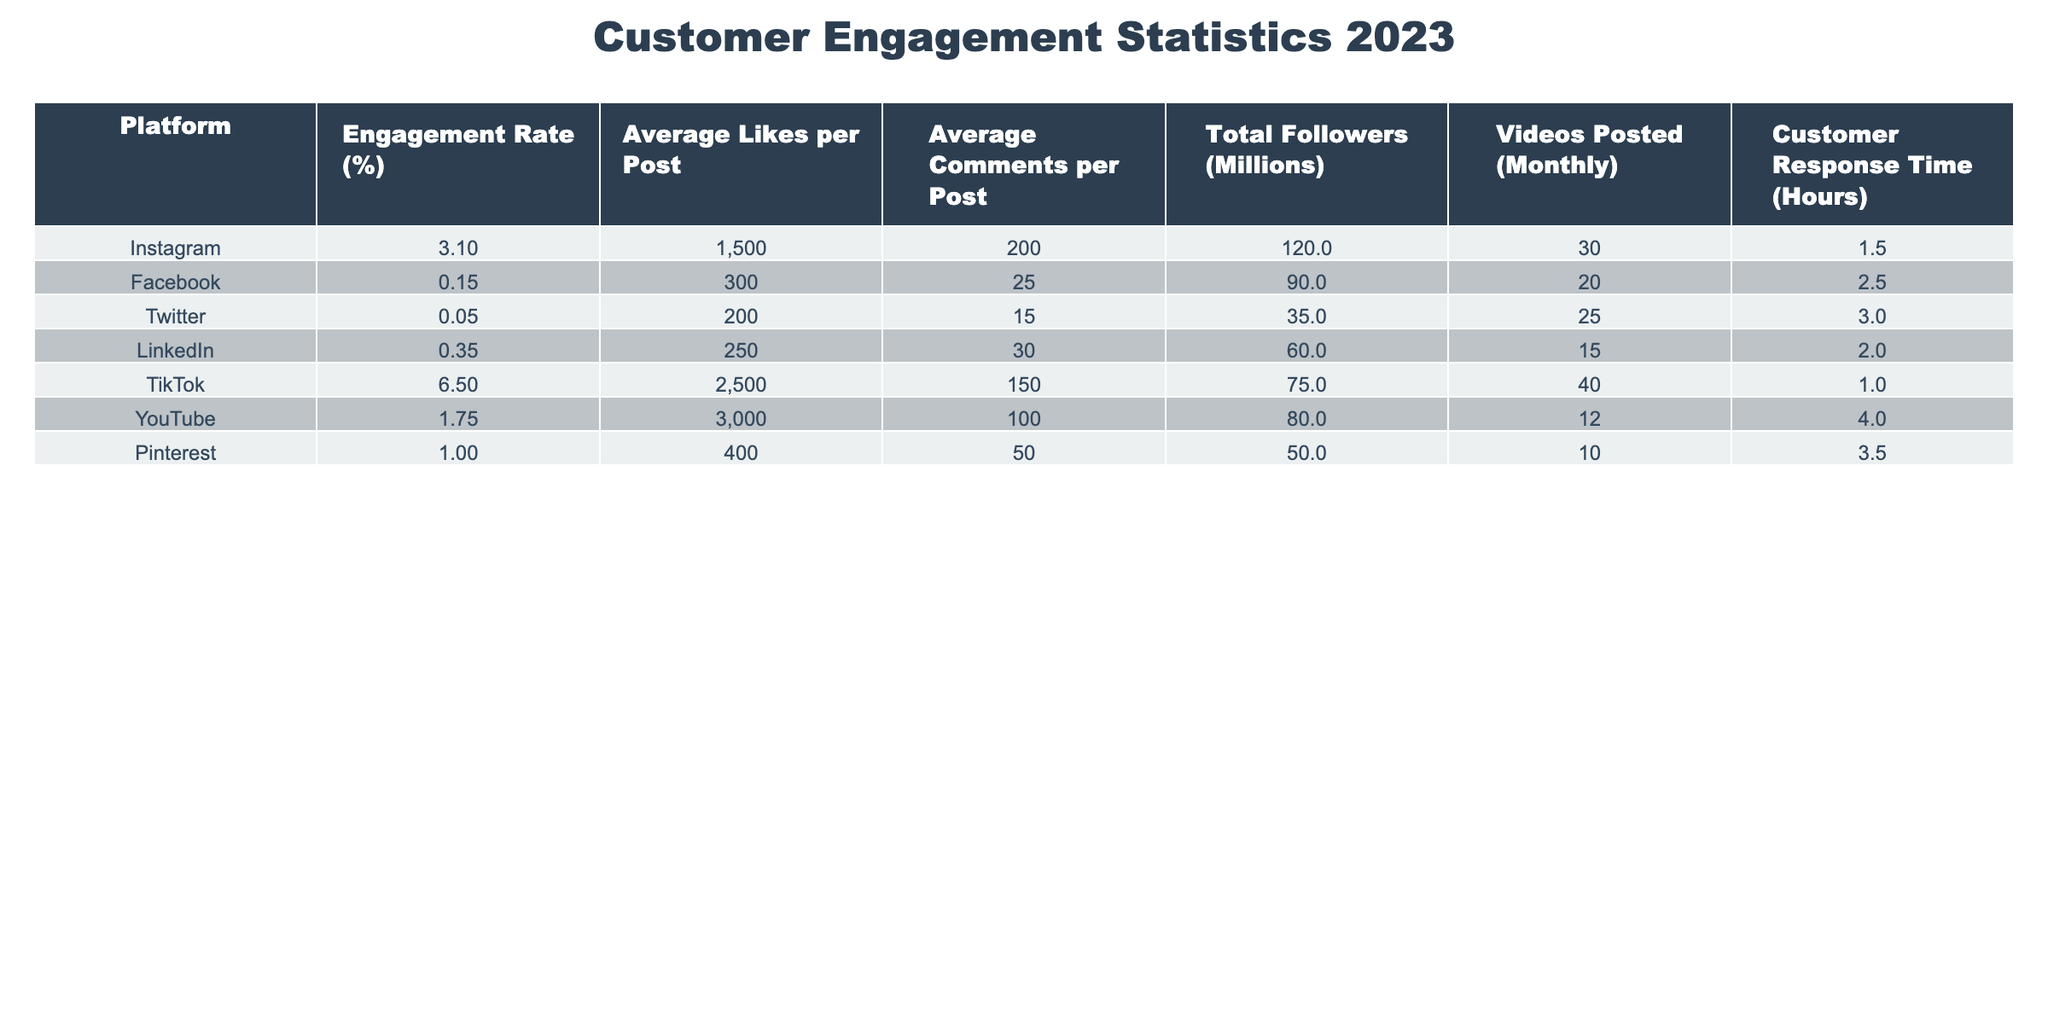What is the engagement rate on TikTok? The table shows a specific value for engagement rate under the TikTok row. Referring to that specific row, TikTok has an engagement rate of 6.50%.
Answer: 6.50% What is the average response time across all platforms? To find the average response time, sum the response times of all platforms: (1.5 + 2.5 + 3.0 + 2.0 + 1.0 + 4.0 + 3.5) = 17.5 hours. Then, divide by the number of platforms (7): 17.5 / 7 = 2.5 hours.
Answer: 2.5 hours Which platform has the highest average likes per post? By checking the average likes per post column, TikTok has 2500 likes, which is higher than all other platforms.
Answer: TikTok Is the engagement rate on Facebook lower than that on Instagram? Comparing the engagement rates from both the Facebook (0.15%) and Instagram (3.10%) rows shows that Facebook has a lower engagement rate than Instagram.
Answer: Yes How many more videos are posted monthly on Instagram compared to LinkedIn? Instagram has 30 videos posted monthly, while LinkedIn has 15. Subtract LinkedIn's videos from Instagram's: 30 - 15 = 15. Hence, 15 more videos are posted monthly on Instagram than LinkedIn.
Answer: 15 more videos What is the total number of followers across all platforms? To calculate the total followers, sum the followers of each platform: (120 + 90 + 35 + 60 + 75 + 80 + 50) million = 510 million.
Answer: 510 million Which social media platform has the highest customer response time? Looking at the customer response time column, YouTube has the highest response time at 4.0 hours.
Answer: YouTube Is the average comments per post on Pinterest higher than the average on Facebook? Comparing the average comments per post, Pinterest has 50 while Facebook has 25. Since 50 is greater than 25, Pinterest has a higher average.
Answer: Yes 